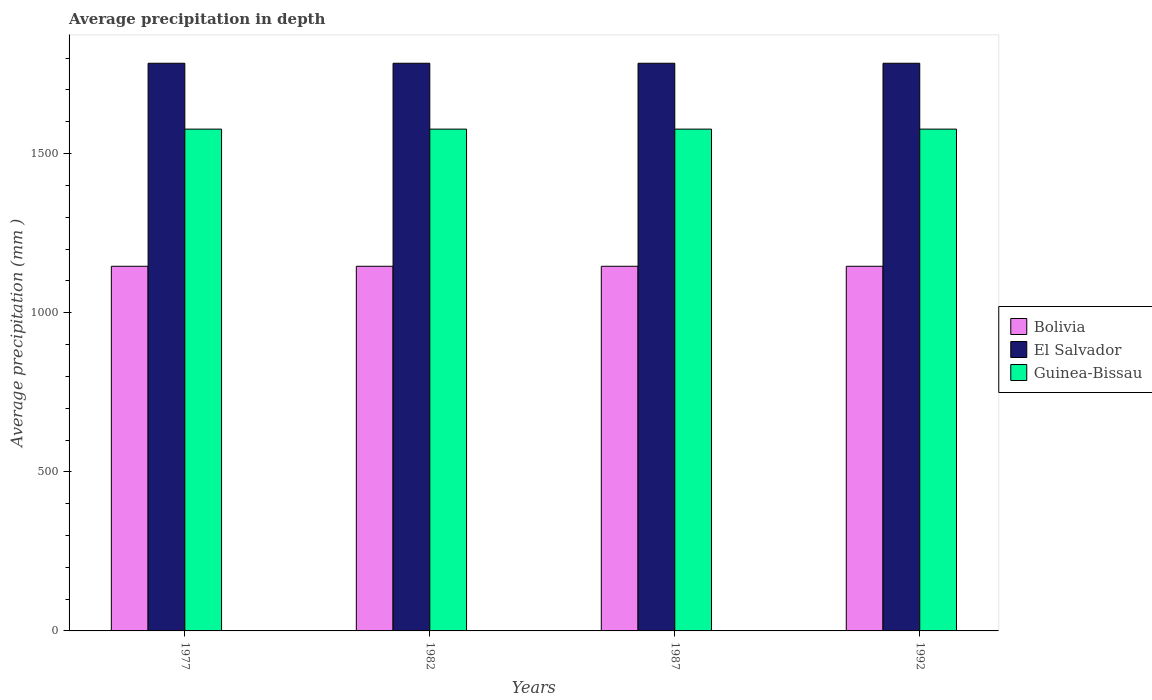Are the number of bars per tick equal to the number of legend labels?
Your response must be concise. Yes. Are the number of bars on each tick of the X-axis equal?
Keep it short and to the point. Yes. How many bars are there on the 4th tick from the right?
Offer a very short reply. 3. In how many cases, is the number of bars for a given year not equal to the number of legend labels?
Your answer should be compact. 0. What is the average precipitation in Guinea-Bissau in 1987?
Your answer should be compact. 1577. Across all years, what is the maximum average precipitation in El Salvador?
Ensure brevity in your answer.  1784. Across all years, what is the minimum average precipitation in Bolivia?
Your answer should be compact. 1146. In which year was the average precipitation in Guinea-Bissau maximum?
Make the answer very short. 1977. In which year was the average precipitation in Bolivia minimum?
Provide a succinct answer. 1977. What is the total average precipitation in Guinea-Bissau in the graph?
Offer a terse response. 6308. What is the difference between the average precipitation in Guinea-Bissau in 1977 and that in 1992?
Your answer should be compact. 0. What is the difference between the average precipitation in Guinea-Bissau in 1992 and the average precipitation in Bolivia in 1977?
Keep it short and to the point. 431. What is the average average precipitation in El Salvador per year?
Offer a very short reply. 1784. In the year 1987, what is the difference between the average precipitation in Bolivia and average precipitation in Guinea-Bissau?
Give a very brief answer. -431. In how many years, is the average precipitation in Guinea-Bissau greater than 1500 mm?
Offer a very short reply. 4. What is the ratio of the average precipitation in El Salvador in 1977 to that in 1987?
Make the answer very short. 1. What is the difference between the highest and the second highest average precipitation in El Salvador?
Offer a very short reply. 0. What does the 3rd bar from the left in 1982 represents?
Give a very brief answer. Guinea-Bissau. What does the 1st bar from the right in 1987 represents?
Make the answer very short. Guinea-Bissau. How many bars are there?
Keep it short and to the point. 12. Are all the bars in the graph horizontal?
Ensure brevity in your answer.  No. How many years are there in the graph?
Your answer should be compact. 4. What is the difference between two consecutive major ticks on the Y-axis?
Offer a very short reply. 500. Are the values on the major ticks of Y-axis written in scientific E-notation?
Keep it short and to the point. No. Does the graph contain any zero values?
Offer a very short reply. No. Does the graph contain grids?
Offer a very short reply. No. How many legend labels are there?
Make the answer very short. 3. How are the legend labels stacked?
Make the answer very short. Vertical. What is the title of the graph?
Your answer should be compact. Average precipitation in depth. Does "Congo (Republic)" appear as one of the legend labels in the graph?
Keep it short and to the point. No. What is the label or title of the X-axis?
Provide a short and direct response. Years. What is the label or title of the Y-axis?
Offer a terse response. Average precipitation (mm ). What is the Average precipitation (mm ) of Bolivia in 1977?
Keep it short and to the point. 1146. What is the Average precipitation (mm ) in El Salvador in 1977?
Provide a succinct answer. 1784. What is the Average precipitation (mm ) in Guinea-Bissau in 1977?
Provide a short and direct response. 1577. What is the Average precipitation (mm ) in Bolivia in 1982?
Keep it short and to the point. 1146. What is the Average precipitation (mm ) in El Salvador in 1982?
Give a very brief answer. 1784. What is the Average precipitation (mm ) in Guinea-Bissau in 1982?
Your answer should be compact. 1577. What is the Average precipitation (mm ) of Bolivia in 1987?
Ensure brevity in your answer.  1146. What is the Average precipitation (mm ) in El Salvador in 1987?
Offer a terse response. 1784. What is the Average precipitation (mm ) of Guinea-Bissau in 1987?
Keep it short and to the point. 1577. What is the Average precipitation (mm ) in Bolivia in 1992?
Your response must be concise. 1146. What is the Average precipitation (mm ) of El Salvador in 1992?
Your answer should be very brief. 1784. What is the Average precipitation (mm ) of Guinea-Bissau in 1992?
Your answer should be compact. 1577. Across all years, what is the maximum Average precipitation (mm ) of Bolivia?
Your response must be concise. 1146. Across all years, what is the maximum Average precipitation (mm ) in El Salvador?
Provide a short and direct response. 1784. Across all years, what is the maximum Average precipitation (mm ) of Guinea-Bissau?
Your answer should be very brief. 1577. Across all years, what is the minimum Average precipitation (mm ) in Bolivia?
Your answer should be compact. 1146. Across all years, what is the minimum Average precipitation (mm ) of El Salvador?
Offer a terse response. 1784. Across all years, what is the minimum Average precipitation (mm ) of Guinea-Bissau?
Ensure brevity in your answer.  1577. What is the total Average precipitation (mm ) in Bolivia in the graph?
Make the answer very short. 4584. What is the total Average precipitation (mm ) in El Salvador in the graph?
Provide a short and direct response. 7136. What is the total Average precipitation (mm ) of Guinea-Bissau in the graph?
Your response must be concise. 6308. What is the difference between the Average precipitation (mm ) of Bolivia in 1977 and that in 1987?
Your answer should be very brief. 0. What is the difference between the Average precipitation (mm ) of El Salvador in 1977 and that in 1987?
Give a very brief answer. 0. What is the difference between the Average precipitation (mm ) in Bolivia in 1977 and that in 1992?
Give a very brief answer. 0. What is the difference between the Average precipitation (mm ) in Bolivia in 1982 and that in 1987?
Keep it short and to the point. 0. What is the difference between the Average precipitation (mm ) of Guinea-Bissau in 1982 and that in 1987?
Provide a succinct answer. 0. What is the difference between the Average precipitation (mm ) of Guinea-Bissau in 1982 and that in 1992?
Give a very brief answer. 0. What is the difference between the Average precipitation (mm ) of Guinea-Bissau in 1987 and that in 1992?
Provide a short and direct response. 0. What is the difference between the Average precipitation (mm ) of Bolivia in 1977 and the Average precipitation (mm ) of El Salvador in 1982?
Ensure brevity in your answer.  -638. What is the difference between the Average precipitation (mm ) in Bolivia in 1977 and the Average precipitation (mm ) in Guinea-Bissau in 1982?
Keep it short and to the point. -431. What is the difference between the Average precipitation (mm ) in El Salvador in 1977 and the Average precipitation (mm ) in Guinea-Bissau in 1982?
Provide a short and direct response. 207. What is the difference between the Average precipitation (mm ) of Bolivia in 1977 and the Average precipitation (mm ) of El Salvador in 1987?
Your response must be concise. -638. What is the difference between the Average precipitation (mm ) of Bolivia in 1977 and the Average precipitation (mm ) of Guinea-Bissau in 1987?
Your answer should be very brief. -431. What is the difference between the Average precipitation (mm ) in El Salvador in 1977 and the Average precipitation (mm ) in Guinea-Bissau in 1987?
Your response must be concise. 207. What is the difference between the Average precipitation (mm ) in Bolivia in 1977 and the Average precipitation (mm ) in El Salvador in 1992?
Ensure brevity in your answer.  -638. What is the difference between the Average precipitation (mm ) of Bolivia in 1977 and the Average precipitation (mm ) of Guinea-Bissau in 1992?
Make the answer very short. -431. What is the difference between the Average precipitation (mm ) of El Salvador in 1977 and the Average precipitation (mm ) of Guinea-Bissau in 1992?
Your answer should be very brief. 207. What is the difference between the Average precipitation (mm ) of Bolivia in 1982 and the Average precipitation (mm ) of El Salvador in 1987?
Offer a very short reply. -638. What is the difference between the Average precipitation (mm ) of Bolivia in 1982 and the Average precipitation (mm ) of Guinea-Bissau in 1987?
Your answer should be compact. -431. What is the difference between the Average precipitation (mm ) in El Salvador in 1982 and the Average precipitation (mm ) in Guinea-Bissau in 1987?
Offer a very short reply. 207. What is the difference between the Average precipitation (mm ) in Bolivia in 1982 and the Average precipitation (mm ) in El Salvador in 1992?
Your response must be concise. -638. What is the difference between the Average precipitation (mm ) of Bolivia in 1982 and the Average precipitation (mm ) of Guinea-Bissau in 1992?
Provide a succinct answer. -431. What is the difference between the Average precipitation (mm ) in El Salvador in 1982 and the Average precipitation (mm ) in Guinea-Bissau in 1992?
Your answer should be very brief. 207. What is the difference between the Average precipitation (mm ) of Bolivia in 1987 and the Average precipitation (mm ) of El Salvador in 1992?
Ensure brevity in your answer.  -638. What is the difference between the Average precipitation (mm ) of Bolivia in 1987 and the Average precipitation (mm ) of Guinea-Bissau in 1992?
Provide a succinct answer. -431. What is the difference between the Average precipitation (mm ) in El Salvador in 1987 and the Average precipitation (mm ) in Guinea-Bissau in 1992?
Provide a short and direct response. 207. What is the average Average precipitation (mm ) of Bolivia per year?
Your answer should be compact. 1146. What is the average Average precipitation (mm ) in El Salvador per year?
Your answer should be compact. 1784. What is the average Average precipitation (mm ) of Guinea-Bissau per year?
Your answer should be compact. 1577. In the year 1977, what is the difference between the Average precipitation (mm ) of Bolivia and Average precipitation (mm ) of El Salvador?
Provide a succinct answer. -638. In the year 1977, what is the difference between the Average precipitation (mm ) of Bolivia and Average precipitation (mm ) of Guinea-Bissau?
Make the answer very short. -431. In the year 1977, what is the difference between the Average precipitation (mm ) of El Salvador and Average precipitation (mm ) of Guinea-Bissau?
Make the answer very short. 207. In the year 1982, what is the difference between the Average precipitation (mm ) in Bolivia and Average precipitation (mm ) in El Salvador?
Your response must be concise. -638. In the year 1982, what is the difference between the Average precipitation (mm ) of Bolivia and Average precipitation (mm ) of Guinea-Bissau?
Provide a short and direct response. -431. In the year 1982, what is the difference between the Average precipitation (mm ) of El Salvador and Average precipitation (mm ) of Guinea-Bissau?
Offer a terse response. 207. In the year 1987, what is the difference between the Average precipitation (mm ) of Bolivia and Average precipitation (mm ) of El Salvador?
Keep it short and to the point. -638. In the year 1987, what is the difference between the Average precipitation (mm ) of Bolivia and Average precipitation (mm ) of Guinea-Bissau?
Your response must be concise. -431. In the year 1987, what is the difference between the Average precipitation (mm ) of El Salvador and Average precipitation (mm ) of Guinea-Bissau?
Offer a terse response. 207. In the year 1992, what is the difference between the Average precipitation (mm ) in Bolivia and Average precipitation (mm ) in El Salvador?
Offer a very short reply. -638. In the year 1992, what is the difference between the Average precipitation (mm ) in Bolivia and Average precipitation (mm ) in Guinea-Bissau?
Offer a very short reply. -431. In the year 1992, what is the difference between the Average precipitation (mm ) of El Salvador and Average precipitation (mm ) of Guinea-Bissau?
Offer a very short reply. 207. What is the ratio of the Average precipitation (mm ) in Bolivia in 1977 to that in 1982?
Make the answer very short. 1. What is the ratio of the Average precipitation (mm ) in Guinea-Bissau in 1977 to that in 1982?
Offer a terse response. 1. What is the ratio of the Average precipitation (mm ) in Bolivia in 1977 to that in 1987?
Offer a terse response. 1. What is the ratio of the Average precipitation (mm ) in El Salvador in 1977 to that in 1987?
Offer a terse response. 1. What is the ratio of the Average precipitation (mm ) in El Salvador in 1977 to that in 1992?
Offer a very short reply. 1. What is the ratio of the Average precipitation (mm ) of Bolivia in 1982 to that in 1987?
Provide a short and direct response. 1. What is the ratio of the Average precipitation (mm ) of El Salvador in 1982 to that in 1987?
Offer a very short reply. 1. What is the ratio of the Average precipitation (mm ) in Bolivia in 1982 to that in 1992?
Provide a short and direct response. 1. What is the ratio of the Average precipitation (mm ) of Guinea-Bissau in 1982 to that in 1992?
Keep it short and to the point. 1. What is the ratio of the Average precipitation (mm ) of El Salvador in 1987 to that in 1992?
Your response must be concise. 1. What is the difference between the highest and the lowest Average precipitation (mm ) in Bolivia?
Offer a terse response. 0. What is the difference between the highest and the lowest Average precipitation (mm ) of El Salvador?
Ensure brevity in your answer.  0. 